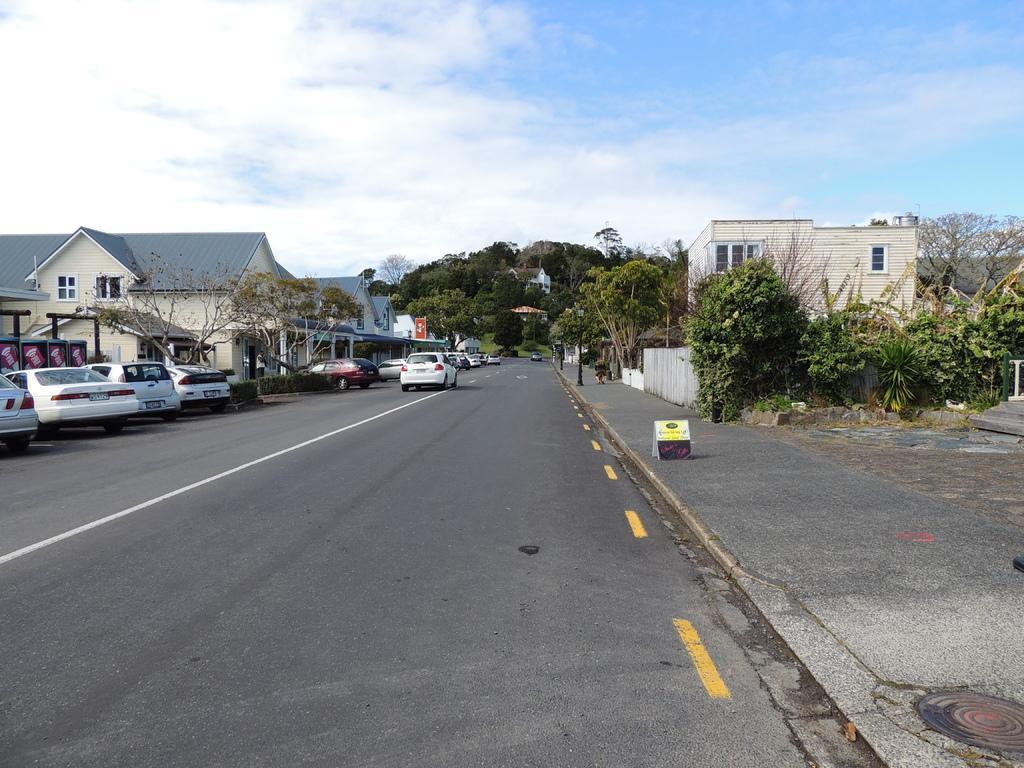In one or two sentences, can you explain what this image depicts? In this image at the bottom there is road, and on the road there are some vehicles. And in the background there are some houses, buildings, trees and some poles and some boards. At the top of the image there is sky. 